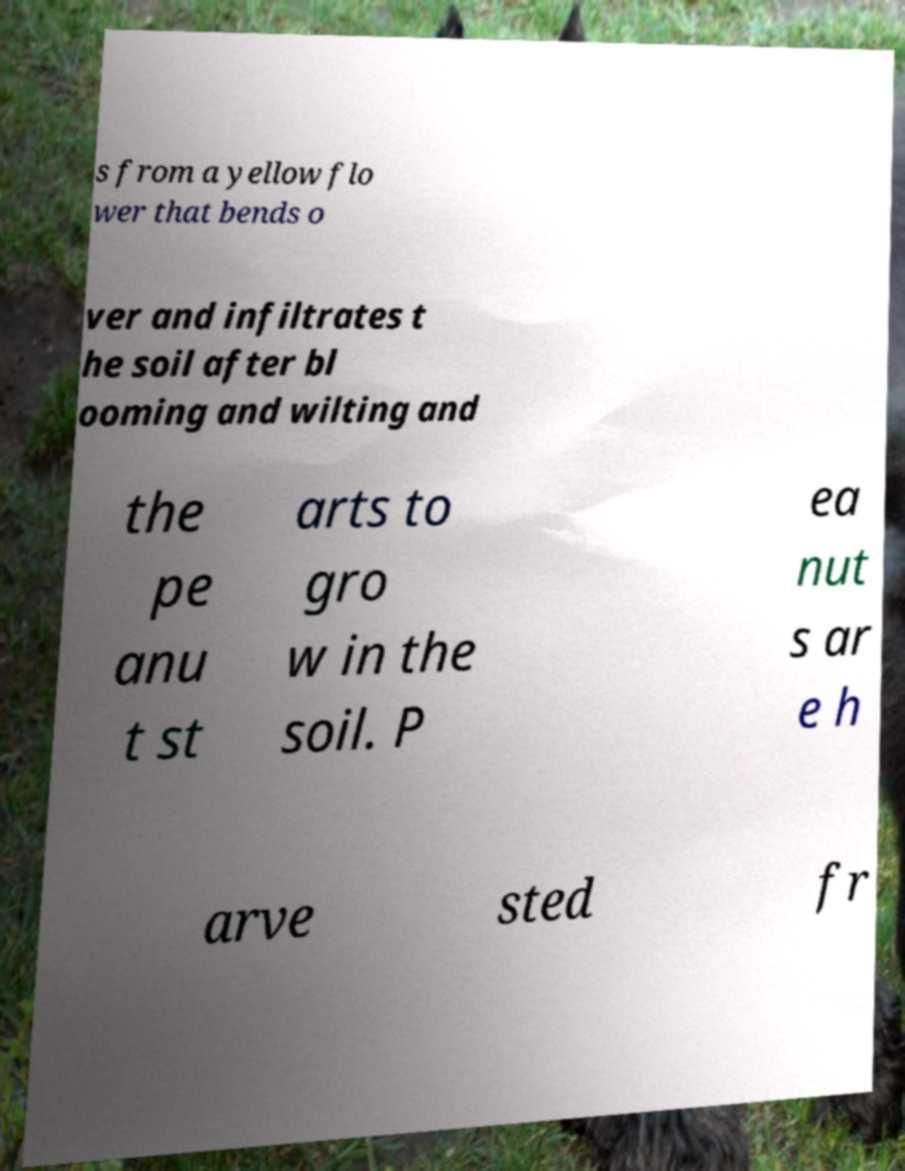Please read and relay the text visible in this image. What does it say? s from a yellow flo wer that bends o ver and infiltrates t he soil after bl ooming and wilting and the pe anu t st arts to gro w in the soil. P ea nut s ar e h arve sted fr 